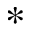Convert formula to latex. <formula><loc_0><loc_0><loc_500><loc_500>*</formula> 